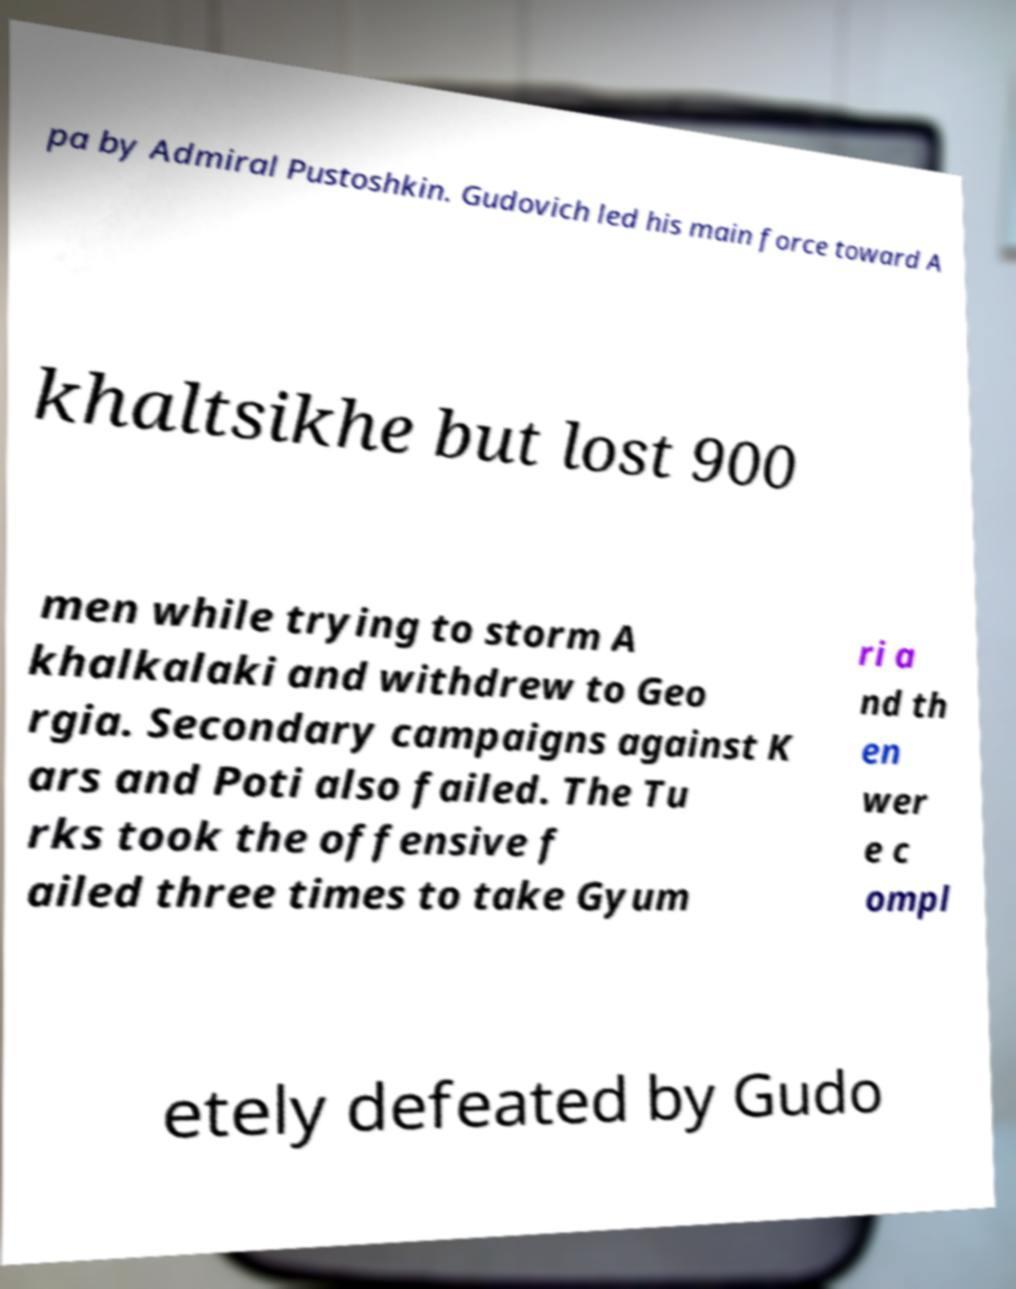Could you extract and type out the text from this image? pa by Admiral Pustoshkin. Gudovich led his main force toward A khaltsikhe but lost 900 men while trying to storm A khalkalaki and withdrew to Geo rgia. Secondary campaigns against K ars and Poti also failed. The Tu rks took the offensive f ailed three times to take Gyum ri a nd th en wer e c ompl etely defeated by Gudo 